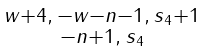<formula> <loc_0><loc_0><loc_500><loc_500>\begin{smallmatrix} w + 4 , \, - w - n - 1 , \, s _ { 4 } + 1 \\ - n + 1 , \, s _ { 4 } \end{smallmatrix}</formula> 